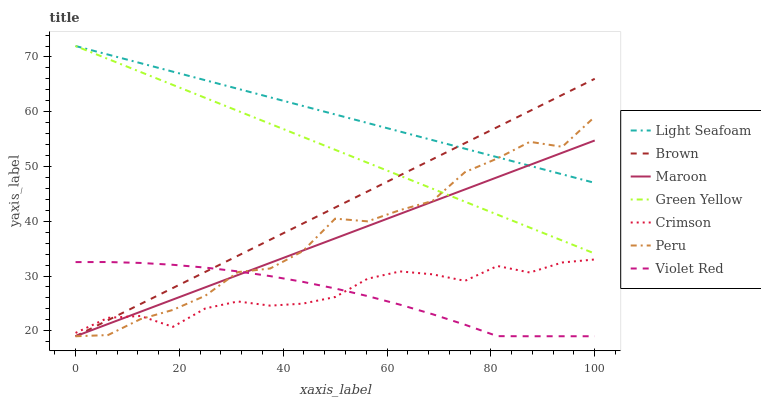Does Violet Red have the minimum area under the curve?
Answer yes or no. Yes. Does Light Seafoam have the maximum area under the curve?
Answer yes or no. Yes. Does Light Seafoam have the minimum area under the curve?
Answer yes or no. No. Does Violet Red have the maximum area under the curve?
Answer yes or no. No. Is Green Yellow the smoothest?
Answer yes or no. Yes. Is Peru the roughest?
Answer yes or no. Yes. Is Violet Red the smoothest?
Answer yes or no. No. Is Violet Red the roughest?
Answer yes or no. No. Does Brown have the lowest value?
Answer yes or no. Yes. Does Light Seafoam have the lowest value?
Answer yes or no. No. Does Green Yellow have the highest value?
Answer yes or no. Yes. Does Violet Red have the highest value?
Answer yes or no. No. Is Crimson less than Light Seafoam?
Answer yes or no. Yes. Is Green Yellow greater than Crimson?
Answer yes or no. Yes. Does Brown intersect Green Yellow?
Answer yes or no. Yes. Is Brown less than Green Yellow?
Answer yes or no. No. Is Brown greater than Green Yellow?
Answer yes or no. No. Does Crimson intersect Light Seafoam?
Answer yes or no. No. 